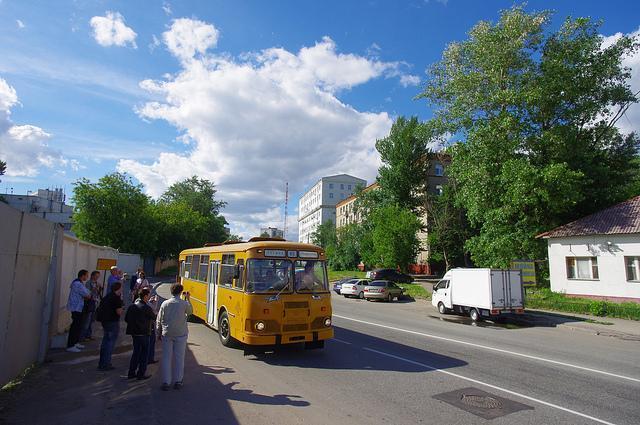How many vehicles are the photo?
Give a very brief answer. 5. How many of these bottles have yellow on the lid?
Give a very brief answer. 0. 